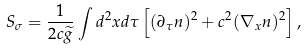Convert formula to latex. <formula><loc_0><loc_0><loc_500><loc_500>S _ { \sigma } = \frac { 1 } { 2 c \widetilde { g } } \int d ^ { 2 } x d \tau \left [ ( \partial _ { \tau } { n } ) ^ { 2 } + c ^ { 2 } ( \nabla _ { x } { n } ) ^ { 2 } \right ] ,</formula> 